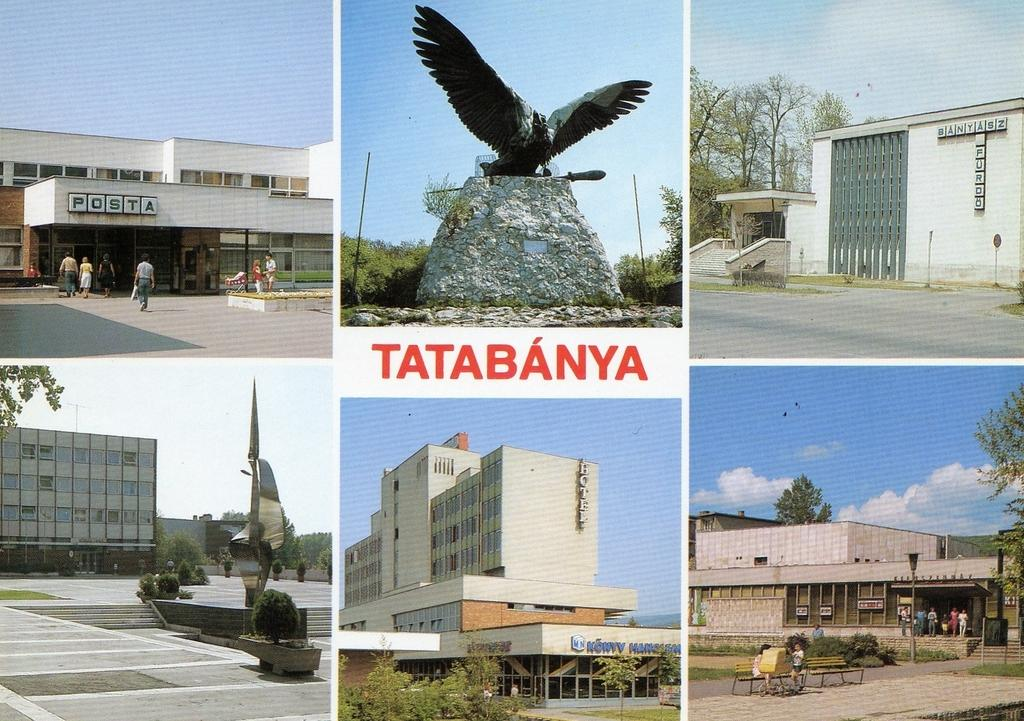What types of structures are depicted in the collage? The collage contains photos of buildings in five images. What other subjects are featured in the collage? The collage contains photos of sculptures in two images. What type of natural elements can be seen in the collage? Trees are visible in the collage. What type of man-made structures are present in the collage? Benches are present in the collage. What type of surface is visible in the collage? Pavement is visible in the collage. What can be seen in the sky in the collage? The sky is visible in the collage, and clouds are present. How many dinosaurs can be seen in the collage? There are no dinosaurs present in the collage. What type of destruction can be observed in the collage? There is no destruction depicted in the collage; it features photos of buildings, sculptures, trees, benches, pavement, the sky, and clouds. 